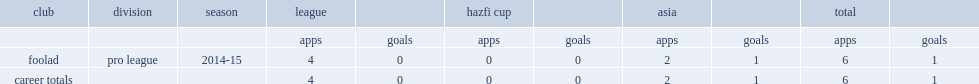Which season did bahman jahantigh make his debut for foolad in the pro league? 2014-15. 